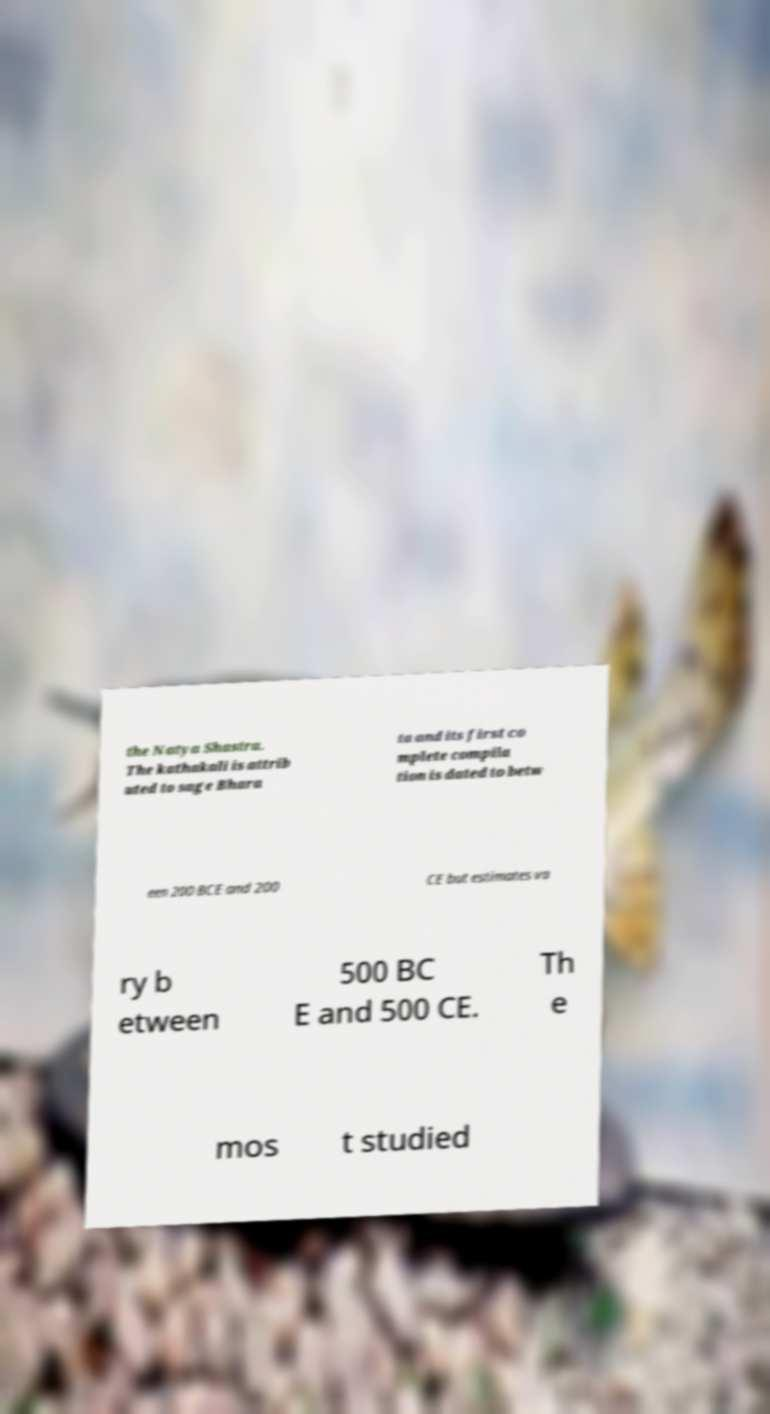Could you extract and type out the text from this image? the Natya Shastra. The kathakali is attrib uted to sage Bhara ta and its first co mplete compila tion is dated to betw een 200 BCE and 200 CE but estimates va ry b etween 500 BC E and 500 CE. Th e mos t studied 